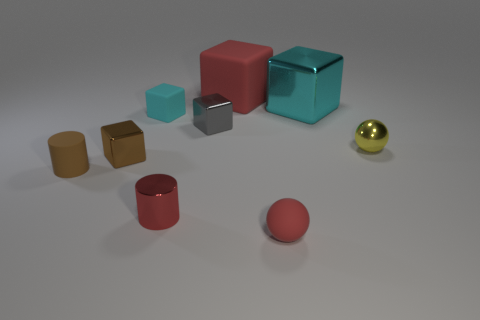What number of objects are either tiny matte spheres or cubes that are in front of the cyan rubber cube?
Keep it short and to the point. 3. Does the cyan object to the right of the gray cube have the same shape as the red thing that is behind the tiny brown cube?
Your answer should be compact. Yes. Are there any other things that have the same color as the tiny metallic ball?
Offer a terse response. No. What shape is the large object that is the same material as the brown cylinder?
Your response must be concise. Cube. What material is the object that is both on the right side of the red shiny object and in front of the small rubber cylinder?
Your answer should be compact. Rubber. Do the matte sphere and the large matte block have the same color?
Your answer should be very brief. Yes. The shiny thing that is the same color as the tiny matte cylinder is what shape?
Offer a very short reply. Cube. How many gray metallic objects are the same shape as the small red rubber object?
Provide a succinct answer. 0. The brown thing that is the same material as the big red block is what size?
Provide a short and direct response. Small. Does the red rubber ball have the same size as the yellow thing?
Provide a short and direct response. Yes. 